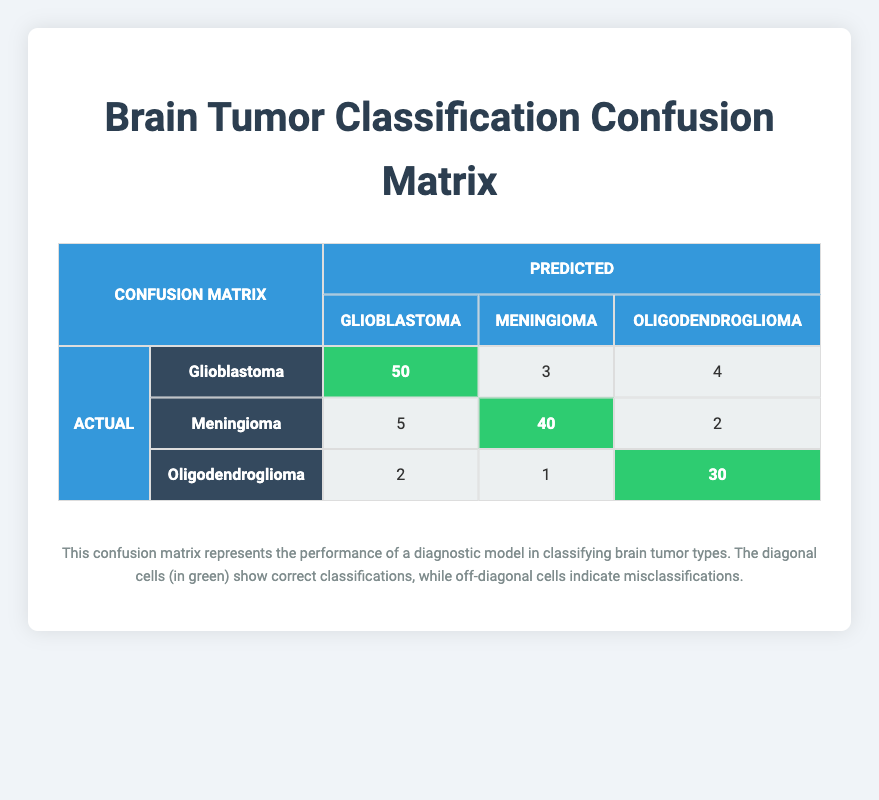What is the total number of predicted Glioblastoma cases? To find the total predicted Glioblastoma cases, we add the counts from the row where predicted is Glioblastoma: 50 (actual Glioblastoma) + 5 (actual Meningioma) + 2 (actual Oligodendroglioma) = 57.
Answer: 57 How many cases were correctly classified as Meningioma? The correctly classified cases of Meningioma are found in the diagonal cell for actual Meningioma in the table, which shows 40.
Answer: 40 What is the total number of actual Oligodendroglioma cases? To find the total actual Oligodendroglioma cases, we add the counts from the row where actual is Oligodendroglioma: 2 (predicted Glioblastoma) + 1 (predicted Meningioma) + 30 (predicted Oligodendroglioma) = 33.
Answer: 33 Is it true that more cases were misclassified as Glioblastoma than as Meningioma? To determine this, we sum the off-diagonal entries for Glioblastoma (5 + 2 = 7) and for Meningioma (3 + 1 = 4). Since 7 > 4, it is true that more were misclassified as Glioblastoma.
Answer: Yes What was the highest number of misclassifications for any brain tumor type? By looking at the misclassifications in the table, for Glioblastoma we have 7 (5 + 2), for Meningioma we have 4 (3 + 1), and for Oligodendroglioma we have 6 (4 + 2). Therefore, the highest number of misclassifications is 7 for Glioblastoma.
Answer: 7 